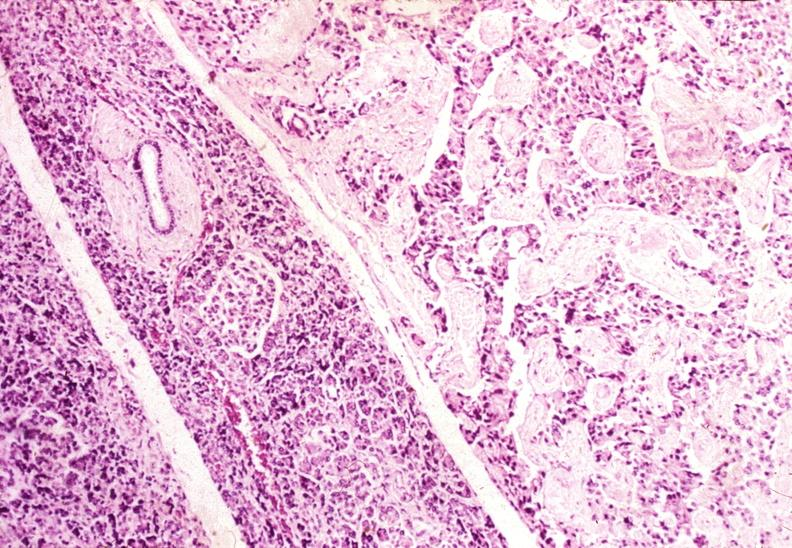does di george syndrome show islet cell carcinoma?
Answer the question using a single word or phrase. No 